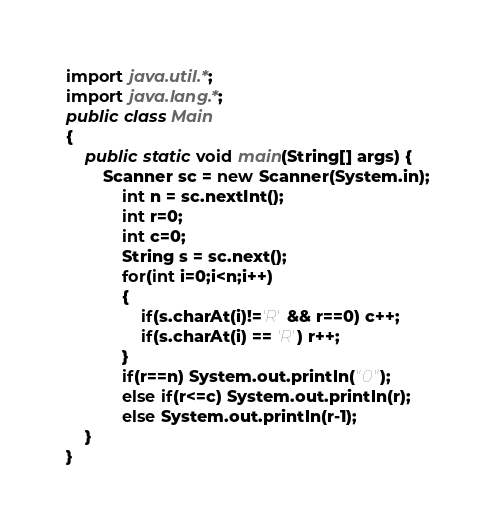Convert code to text. <code><loc_0><loc_0><loc_500><loc_500><_Java_>import java.util.*;
import java.lang.*;
public class Main
{
	public static void main(String[] args) {
		Scanner sc = new Scanner(System.in);
			int n = sc.nextInt();
			int r=0;
			int c=0;
			String s = sc.next();
			for(int i=0;i<n;i++)
			{
				if(s.charAt(i)!='R' && r==0) c++;
				if(s.charAt(i) == 'R') r++;
			}
			if(r==n) System.out.println("0");
			else if(r<=c) System.out.println(r);
			else System.out.println(r-1);
	}
}
</code> 